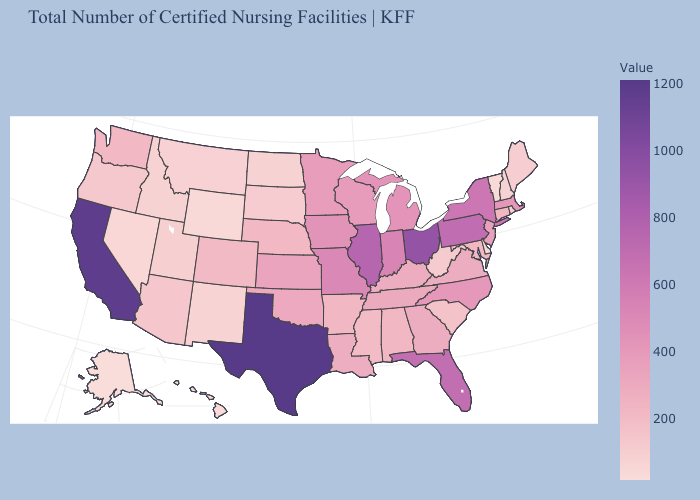Among the states that border North Dakota , does Minnesota have the lowest value?
Give a very brief answer. No. Among the states that border Iowa , does South Dakota have the lowest value?
Give a very brief answer. Yes. Is the legend a continuous bar?
Short answer required. Yes. Does Washington have a lower value than Pennsylvania?
Keep it brief. Yes. Among the states that border California , which have the highest value?
Keep it brief. Arizona. Which states have the lowest value in the Northeast?
Concise answer only. Vermont. Does Texas have the highest value in the USA?
Concise answer only. Yes. Which states have the lowest value in the USA?
Quick response, please. Alaska. 